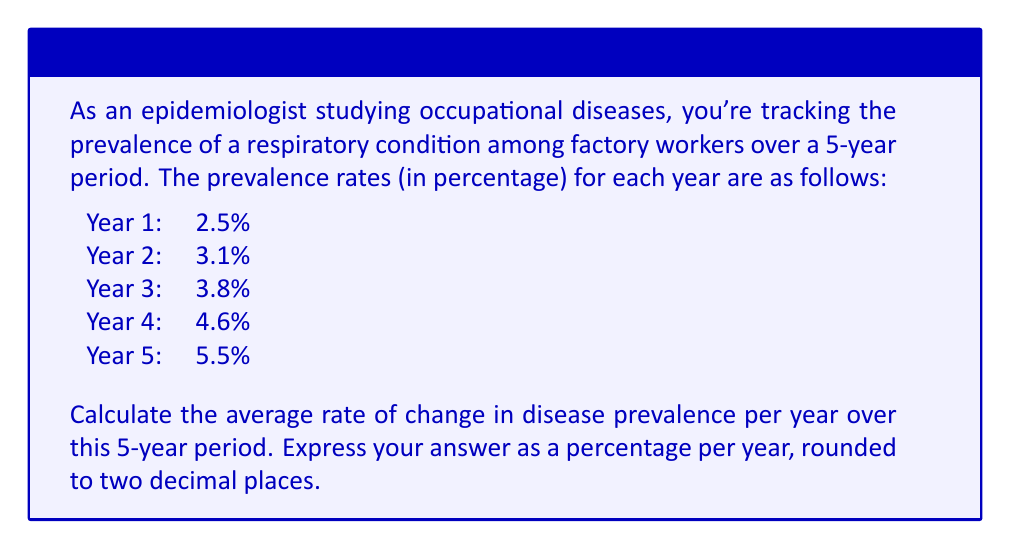Could you help me with this problem? To solve this problem, we need to follow these steps:

1) First, let's calculate the total change in prevalence over the 5-year period:
   $\text{Total change} = \text{Final value} - \text{Initial value}$
   $\text{Total change} = 5.5\% - 2.5\% = 3\%$

2) Now, we need to find the rate of change per year. Since we're looking at a 5-year period, we'll divide the total change by 5:

   $$\text{Average rate of change} = \frac{\text{Total change}}{\text{Number of years}}$$

   $$\text{Average rate of change} = \frac{3\%}{5} = 0.6\% \text{ per year}$$

3) The question asks for the result rounded to two decimal places, but our result (0.6%) already has only one decimal place, so no further rounding is necessary.

This rate of 0.6% per year represents the average increase in disease prevalence each year over the 5-year period.
Answer: 0.60% per year 